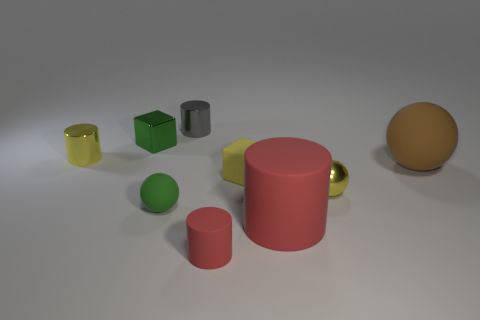Subtract all large red cylinders. How many cylinders are left? 3 Subtract all blocks. How many objects are left? 7 Subtract all purple spheres. How many brown cylinders are left? 0 Subtract all small yellow cubes. Subtract all metal cylinders. How many objects are left? 6 Add 2 small yellow balls. How many small yellow balls are left? 3 Add 4 large red matte cylinders. How many large red matte cylinders exist? 5 Add 1 purple spheres. How many objects exist? 10 Subtract all yellow cylinders. How many cylinders are left? 3 Subtract 0 blue cylinders. How many objects are left? 9 Subtract 1 cylinders. How many cylinders are left? 3 